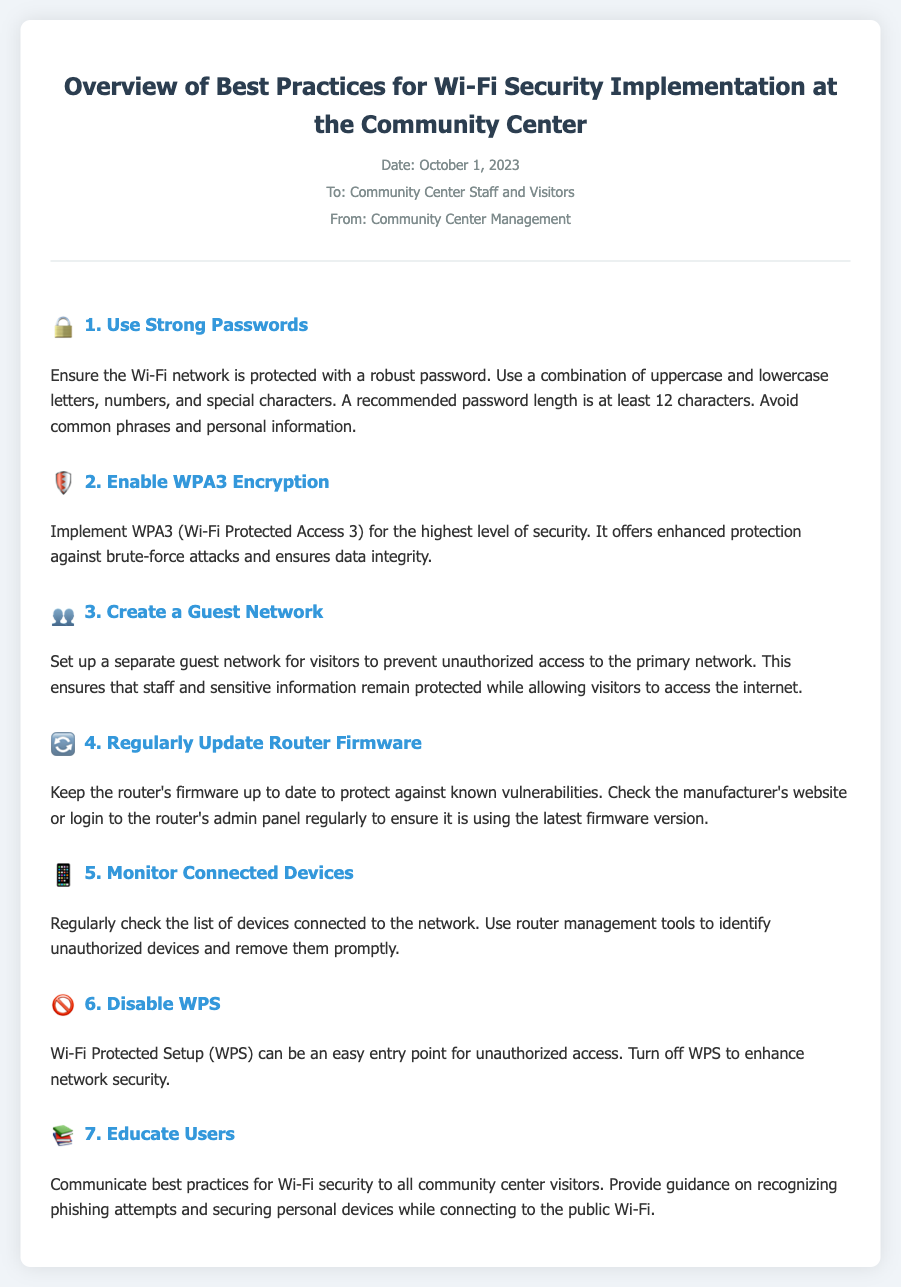What is the date of the memo? The date of the memo is clearly stated in the document header as "October 1, 2023."
Answer: October 1, 2023 What does WPA3 stand for? The document describes WPA3 as "Wi-Fi Protected Access 3," which is stated in the section about encryption.
Answer: Wi-Fi Protected Access 3 How many security best practices are listed? The document outlines a total of seven security best practices for Wi-Fi implementation.
Answer: Seven What should be avoided when creating Wi-Fi passwords? The memo advises to avoid "common phrases and personal information" when setting passwords.
Answer: Common phrases and personal information Which section discusses the separate network for visitors? The section about creating a guest network mentions setting up a separate network for visitors specifically.
Answer: Create a Guest Network What action should be taken with the router firmware? The document emphasizes the importance of regularly updating the router firmware for security purposes.
Answer: Regularly Update Router Firmware Which two security measures involve monitoring? Both "Monitor Connected Devices" and "Educate Users" involve keeping an eye on network activity and user behavior.
Answer: Monitor Connected Devices, Educate Users What does disabling WPS enhance? The memo states that disabling WPS enhances network security against unauthorized access.
Answer: Network security 